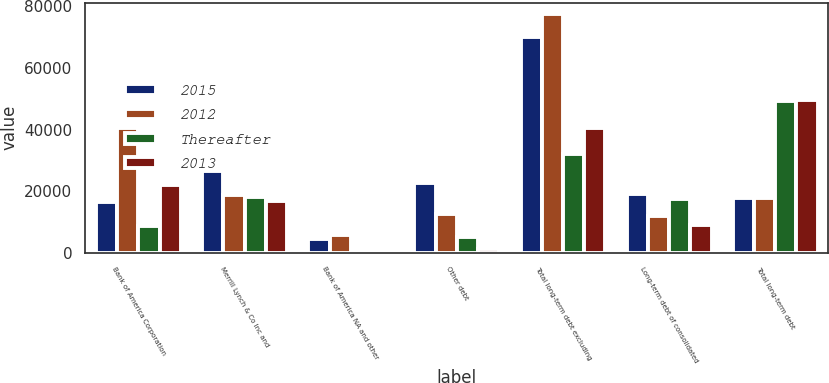Convert chart. <chart><loc_0><loc_0><loc_500><loc_500><stacked_bar_chart><ecel><fcel>Bank of America Corporation<fcel>Merrill Lynch & Co Inc and<fcel>Bank of America NA and other<fcel>Other debt<fcel>Total long-term debt excluding<fcel>Long-term debt of consolidated<fcel>Total long-term debt<nl><fcel>2015<fcel>16419<fcel>26554<fcel>4382<fcel>22760<fcel>70115<fcel>19136<fcel>17783.5<nl><fcel>2012<fcel>40432<fcel>18611<fcel>5796<fcel>12549<fcel>77388<fcel>11800<fcel>17783.5<nl><fcel>Thereafter<fcel>8731<fcel>18053<fcel>86<fcel>5031<fcel>31901<fcel>17514<fcel>49415<nl><fcel>2013<fcel>21890<fcel>16650<fcel>503<fcel>1293<fcel>40336<fcel>9103<fcel>49439<nl></chart> 